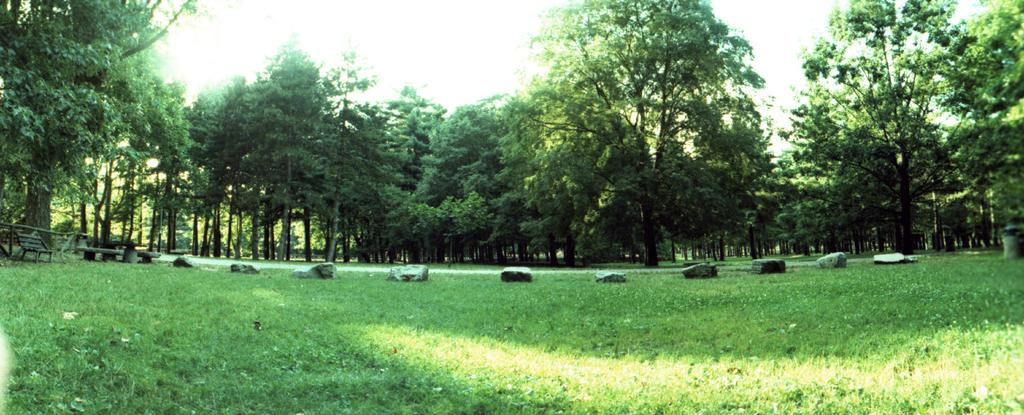What type of vegetation can be seen in the image? There are trees in the image. Where is the bench located in the image? The bench is on the left side of the image. What is the ground made of in the image? There is grass and stones on the ground in the image. What is visible in the background of the image? There is a sky visible in the background of the image. What type of writing instrument is being used by the trees in the image? There are no writing instruments present in the image, as the trees are not depicted as using any. What is the aftermath of the crayon usage in the image? There is no crayon usage in the image, so there is no aftermath to discuss. 